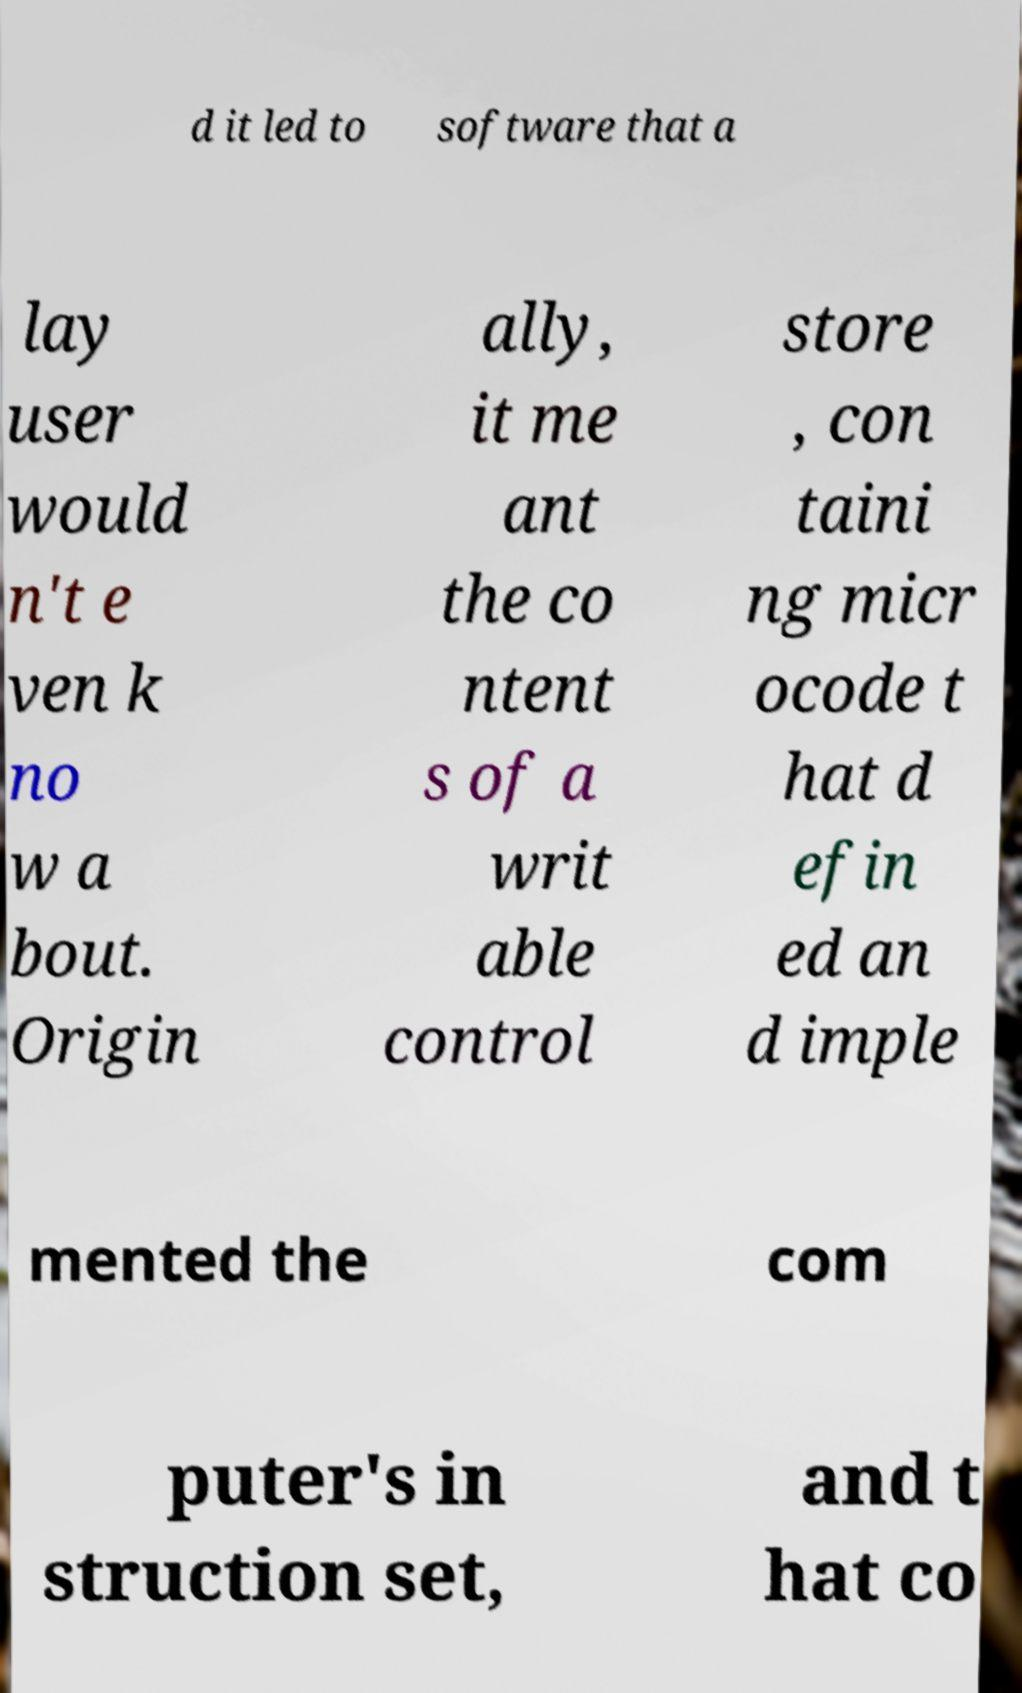Could you extract and type out the text from this image? d it led to software that a lay user would n't e ven k no w a bout. Origin ally, it me ant the co ntent s of a writ able control store , con taini ng micr ocode t hat d efin ed an d imple mented the com puter's in struction set, and t hat co 